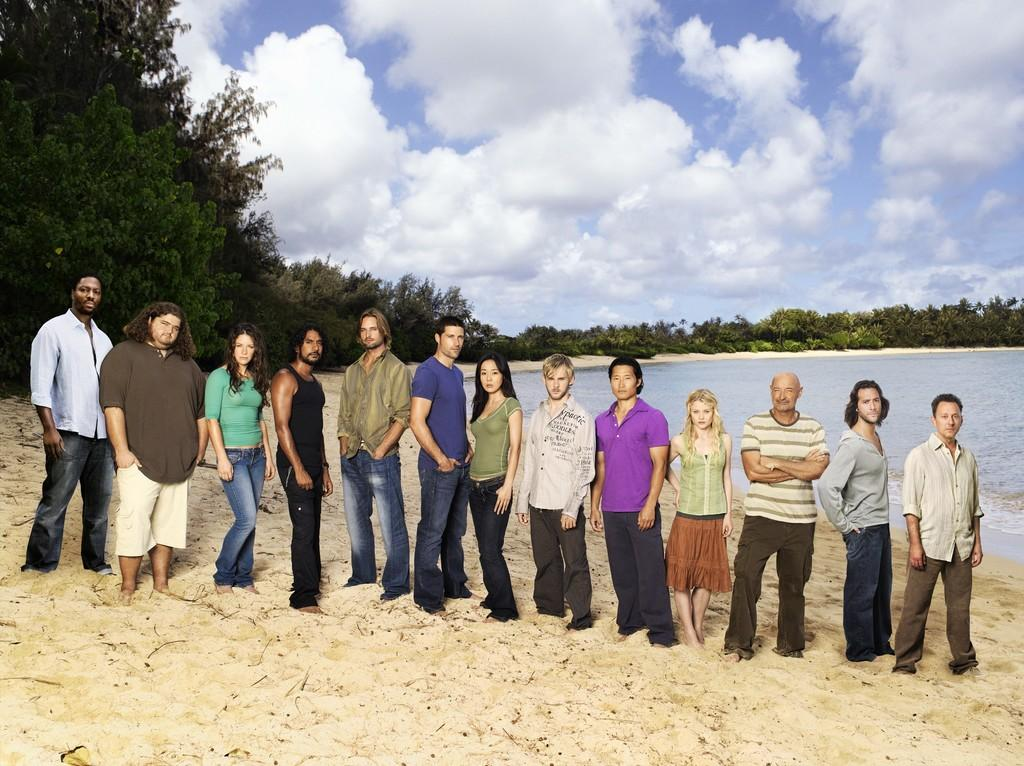How many people are in the image? There is a group of persons in the image, but the exact number is not specified. Where are the persons located in the image? The group of persons is standing at the seashore. What can be seen in the background of the image? There is water, trees, and a cloudy sky visible in the background of the image. Can you see any toads in the image? There is no mention of toads in the image, so it cannot be determined if any are present. 